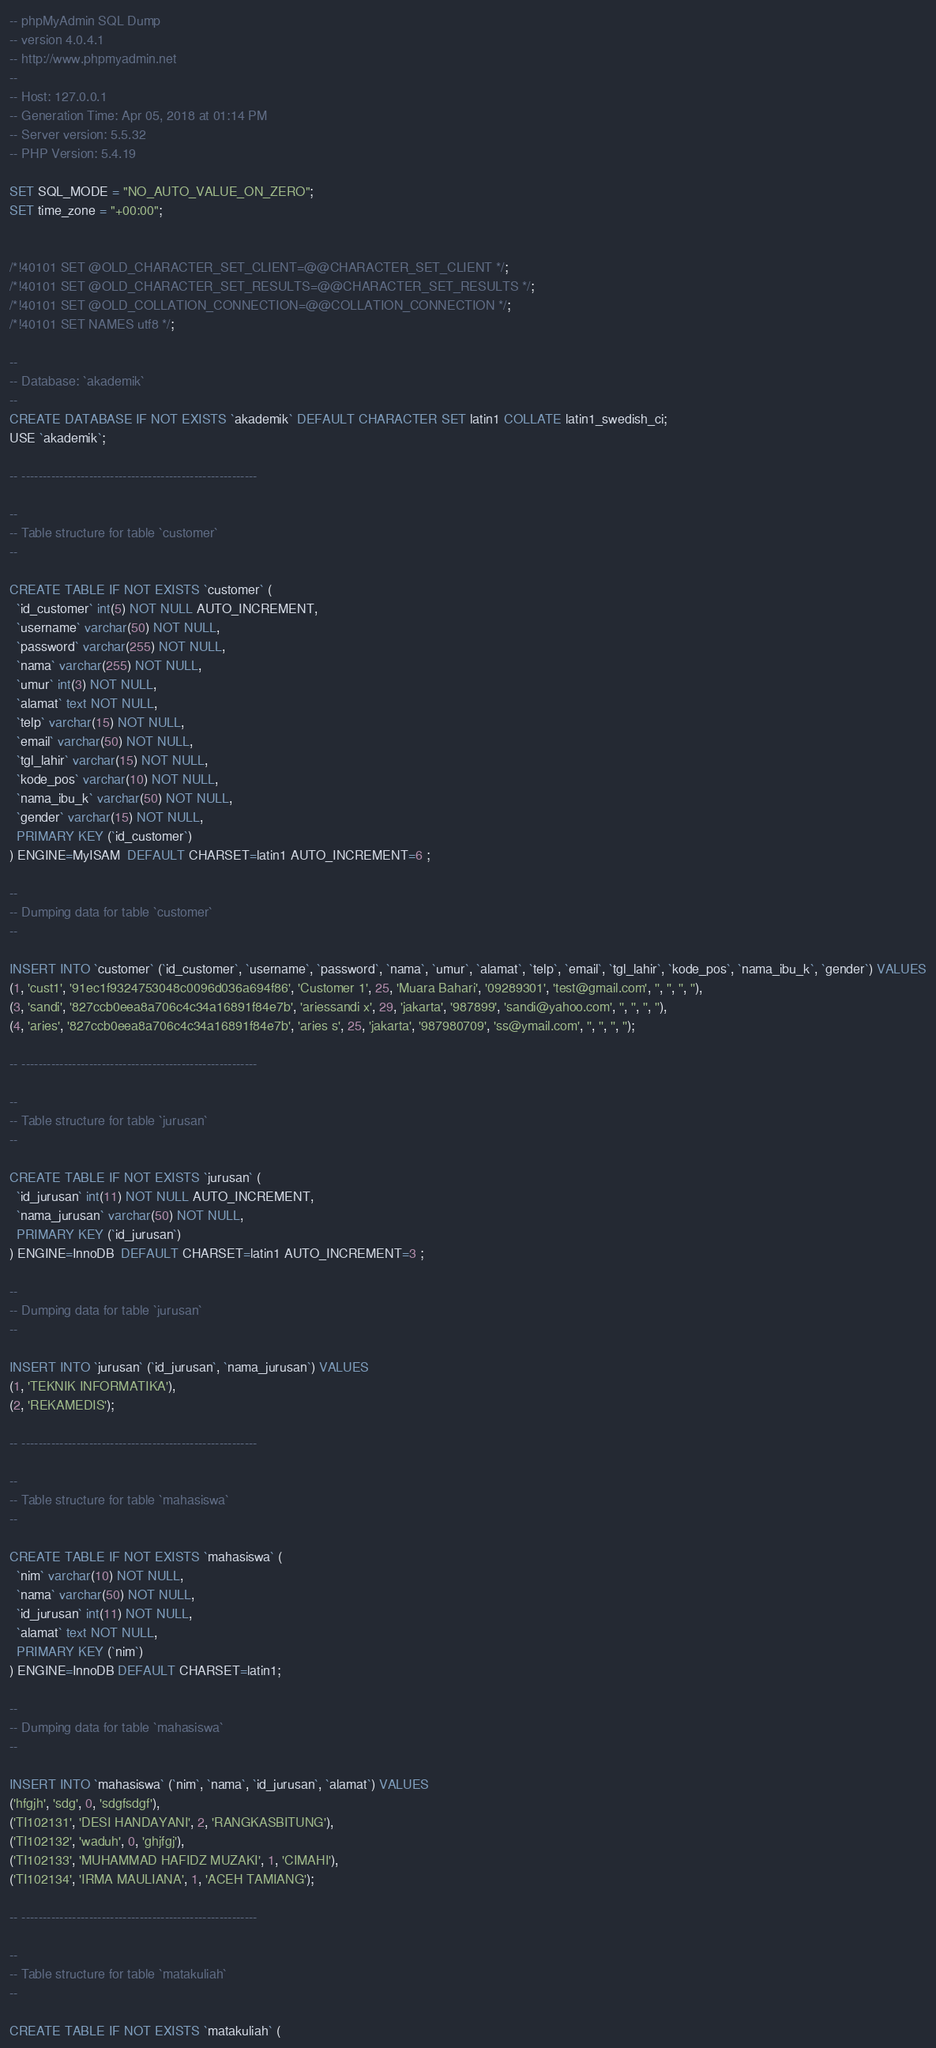<code> <loc_0><loc_0><loc_500><loc_500><_SQL_>-- phpMyAdmin SQL Dump
-- version 4.0.4.1
-- http://www.phpmyadmin.net
--
-- Host: 127.0.0.1
-- Generation Time: Apr 05, 2018 at 01:14 PM
-- Server version: 5.5.32
-- PHP Version: 5.4.19

SET SQL_MODE = "NO_AUTO_VALUE_ON_ZERO";
SET time_zone = "+00:00";


/*!40101 SET @OLD_CHARACTER_SET_CLIENT=@@CHARACTER_SET_CLIENT */;
/*!40101 SET @OLD_CHARACTER_SET_RESULTS=@@CHARACTER_SET_RESULTS */;
/*!40101 SET @OLD_COLLATION_CONNECTION=@@COLLATION_CONNECTION */;
/*!40101 SET NAMES utf8 */;

--
-- Database: `akademik`
--
CREATE DATABASE IF NOT EXISTS `akademik` DEFAULT CHARACTER SET latin1 COLLATE latin1_swedish_ci;
USE `akademik`;

-- --------------------------------------------------------

--
-- Table structure for table `customer`
--

CREATE TABLE IF NOT EXISTS `customer` (
  `id_customer` int(5) NOT NULL AUTO_INCREMENT,
  `username` varchar(50) NOT NULL,
  `password` varchar(255) NOT NULL,
  `nama` varchar(255) NOT NULL,
  `umur` int(3) NOT NULL,
  `alamat` text NOT NULL,
  `telp` varchar(15) NOT NULL,
  `email` varchar(50) NOT NULL,
  `tgl_lahir` varchar(15) NOT NULL,
  `kode_pos` varchar(10) NOT NULL,
  `nama_ibu_k` varchar(50) NOT NULL,
  `gender` varchar(15) NOT NULL,
  PRIMARY KEY (`id_customer`)
) ENGINE=MyISAM  DEFAULT CHARSET=latin1 AUTO_INCREMENT=6 ;

--
-- Dumping data for table `customer`
--

INSERT INTO `customer` (`id_customer`, `username`, `password`, `nama`, `umur`, `alamat`, `telp`, `email`, `tgl_lahir`, `kode_pos`, `nama_ibu_k`, `gender`) VALUES
(1, 'cust1', '91ec1f9324753048c0096d036a694f86', 'Customer 1', 25, 'Muara Bahari', '09289301', 'test@gmail.com', '', '', '', ''),
(3, 'sandi', '827ccb0eea8a706c4c34a16891f84e7b', 'ariessandi x', 29, 'jakarta', '987899', 'sandi@yahoo.com', '', '', '', ''),
(4, 'aries', '827ccb0eea8a706c4c34a16891f84e7b', 'aries s', 25, 'jakarta', '987980709', 'ss@ymail.com', '', '', '', '');

-- --------------------------------------------------------

--
-- Table structure for table `jurusan`
--

CREATE TABLE IF NOT EXISTS `jurusan` (
  `id_jurusan` int(11) NOT NULL AUTO_INCREMENT,
  `nama_jurusan` varchar(50) NOT NULL,
  PRIMARY KEY (`id_jurusan`)
) ENGINE=InnoDB  DEFAULT CHARSET=latin1 AUTO_INCREMENT=3 ;

--
-- Dumping data for table `jurusan`
--

INSERT INTO `jurusan` (`id_jurusan`, `nama_jurusan`) VALUES
(1, 'TEKNIK INFORMATIKA'),
(2, 'REKAMEDIS');

-- --------------------------------------------------------

--
-- Table structure for table `mahasiswa`
--

CREATE TABLE IF NOT EXISTS `mahasiswa` (
  `nim` varchar(10) NOT NULL,
  `nama` varchar(50) NOT NULL,
  `id_jurusan` int(11) NOT NULL,
  `alamat` text NOT NULL,
  PRIMARY KEY (`nim`)
) ENGINE=InnoDB DEFAULT CHARSET=latin1;

--
-- Dumping data for table `mahasiswa`
--

INSERT INTO `mahasiswa` (`nim`, `nama`, `id_jurusan`, `alamat`) VALUES
('hfgjh', 'sdg', 0, 'sdgfsdgf'),
('TI102131', 'DESI HANDAYANI', 2, 'RANGKASBITUNG'),
('TI102132', 'waduh', 0, 'ghjfgj'),
('TI102133', 'MUHAMMAD HAFIDZ MUZAKI', 1, 'CIMAHI'),
('TI102134', 'IRMA MAULIANA', 1, 'ACEH TAMIANG');

-- --------------------------------------------------------

--
-- Table structure for table `matakuliah`
--

CREATE TABLE IF NOT EXISTS `matakuliah` (</code> 